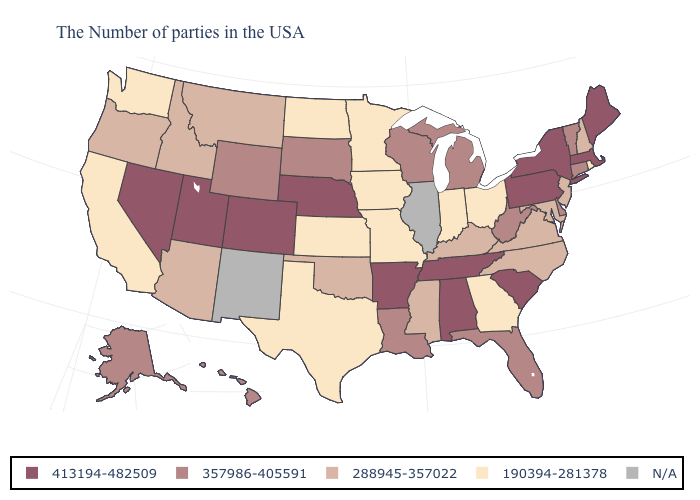What is the value of Alabama?
Concise answer only. 413194-482509. What is the value of Arizona?
Write a very short answer. 288945-357022. Name the states that have a value in the range 190394-281378?
Write a very short answer. Rhode Island, Ohio, Georgia, Indiana, Missouri, Minnesota, Iowa, Kansas, Texas, North Dakota, California, Washington. Among the states that border Arizona , does California have the lowest value?
Keep it brief. Yes. What is the value of Vermont?
Short answer required. 357986-405591. Name the states that have a value in the range N/A?
Quick response, please. Illinois, New Mexico. Does Colorado have the highest value in the USA?
Give a very brief answer. Yes. Name the states that have a value in the range 413194-482509?
Short answer required. Maine, Massachusetts, New York, Pennsylvania, South Carolina, Alabama, Tennessee, Arkansas, Nebraska, Colorado, Utah, Nevada. Name the states that have a value in the range 413194-482509?
Be succinct. Maine, Massachusetts, New York, Pennsylvania, South Carolina, Alabama, Tennessee, Arkansas, Nebraska, Colorado, Utah, Nevada. What is the value of Wisconsin?
Concise answer only. 357986-405591. What is the highest value in the West ?
Keep it brief. 413194-482509. Which states have the lowest value in the Northeast?
Short answer required. Rhode Island. 